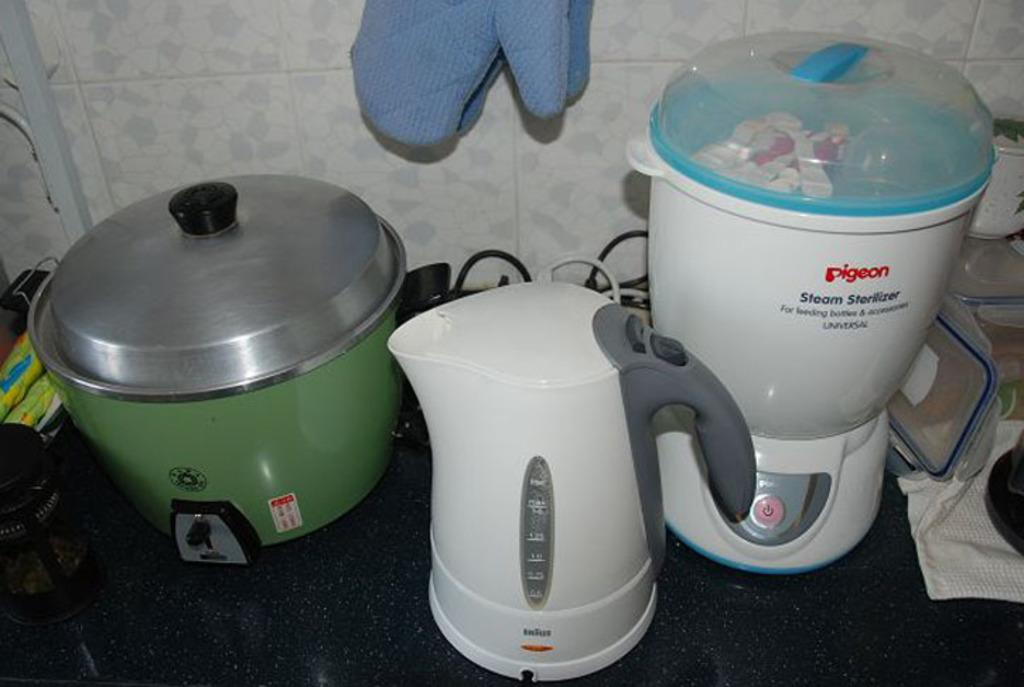<image>
Present a compact description of the photo's key features. three different kitchen appliances with the brand pigeon. 